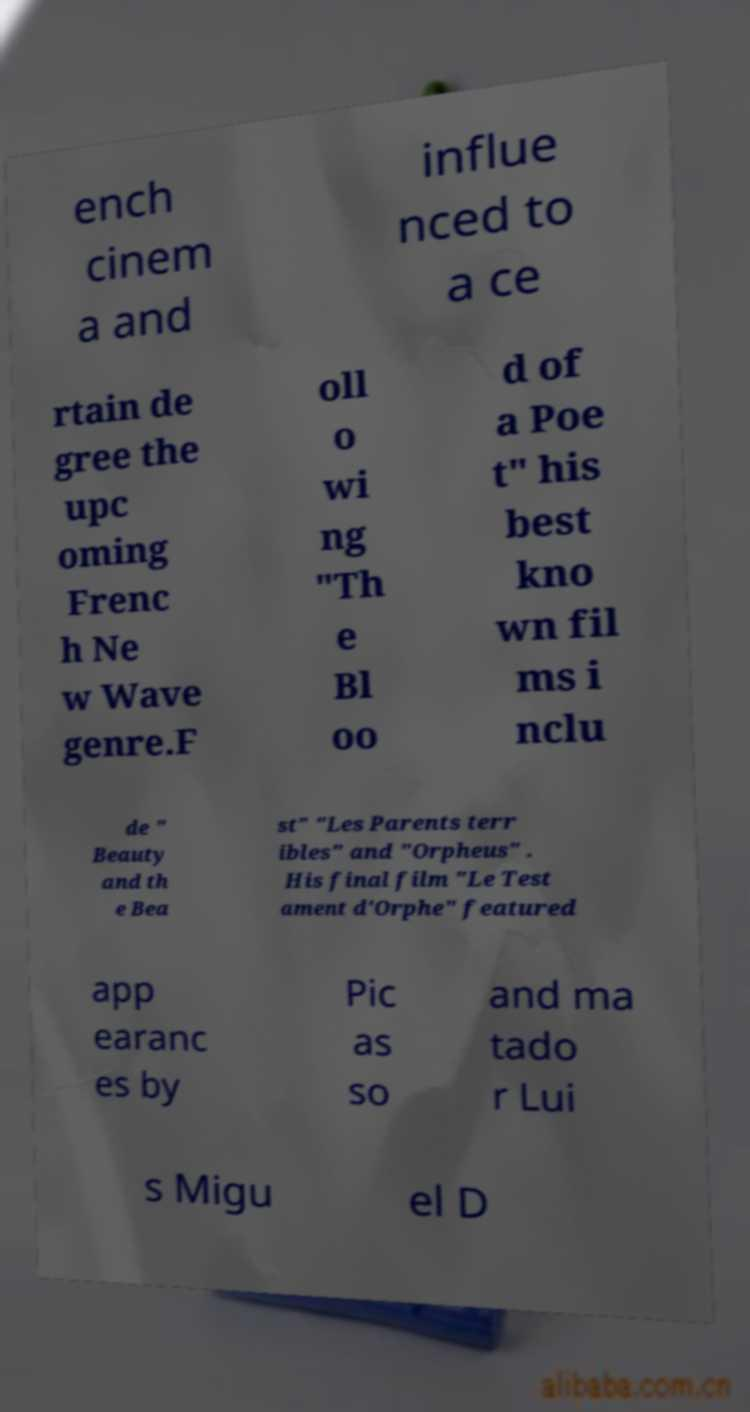Can you accurately transcribe the text from the provided image for me? ench cinem a and influe nced to a ce rtain de gree the upc oming Frenc h Ne w Wave genre.F oll o wi ng "Th e Bl oo d of a Poe t" his best kno wn fil ms i nclu de " Beauty and th e Bea st" "Les Parents terr ibles" and "Orpheus" . His final film "Le Test ament d'Orphe" featured app earanc es by Pic as so and ma tado r Lui s Migu el D 